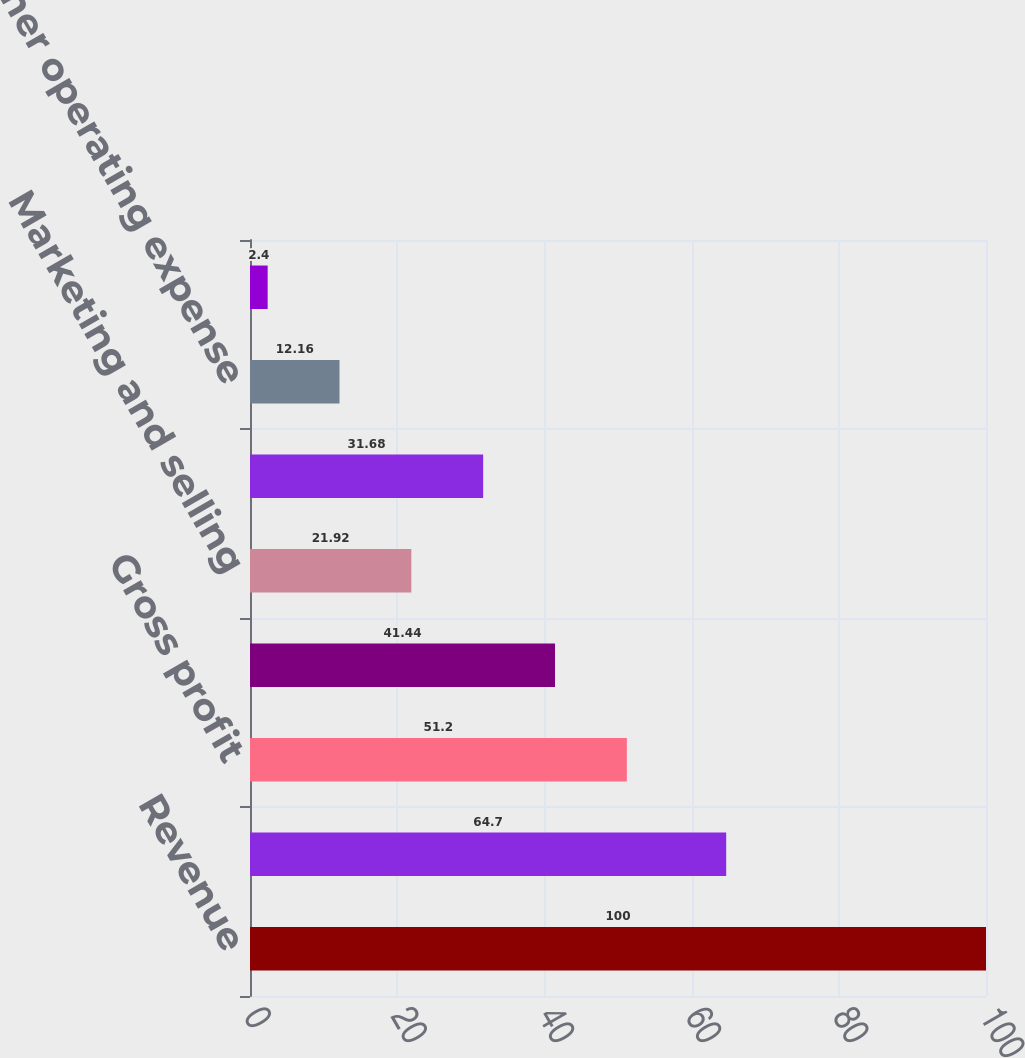Convert chart. <chart><loc_0><loc_0><loc_500><loc_500><bar_chart><fcel>Revenue<fcel>Cost of goods sold<fcel>Gross profit<fcel>Research and development<fcel>Marketing and selling<fcel>General and administrative<fcel>Other operating expense<fcel>Operating income<nl><fcel>100<fcel>64.7<fcel>51.2<fcel>41.44<fcel>21.92<fcel>31.68<fcel>12.16<fcel>2.4<nl></chart> 